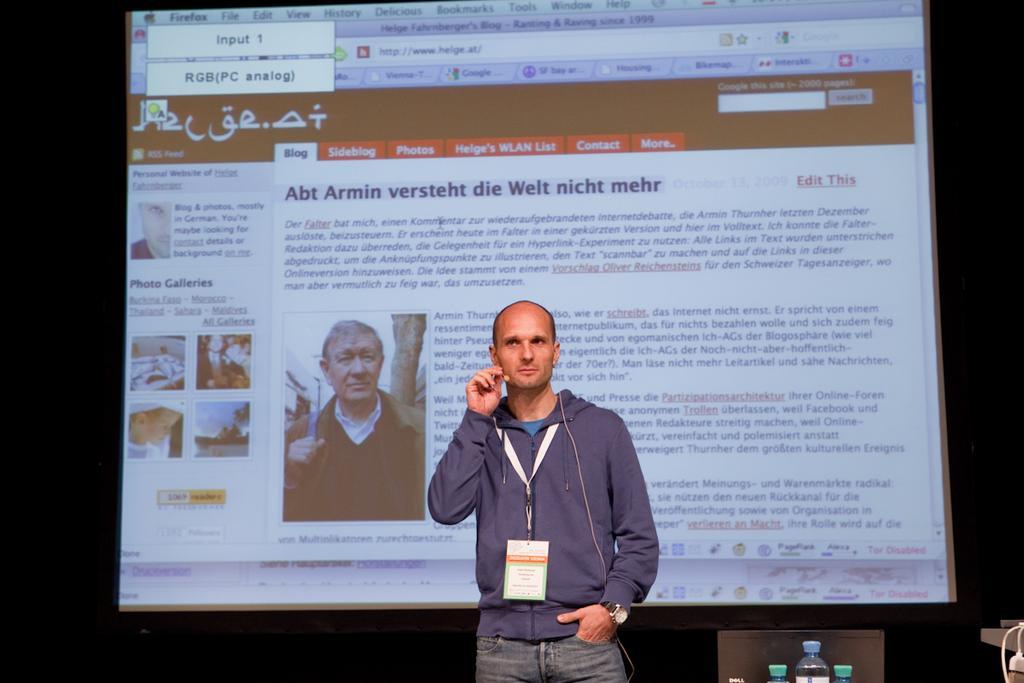Could you give a brief overview of what you see in this image? In this picture we can see a person. There are a few bottles and white objects on the right side. We can see a screen in the background. On this screen there are a few people, some text and photo galleries. 